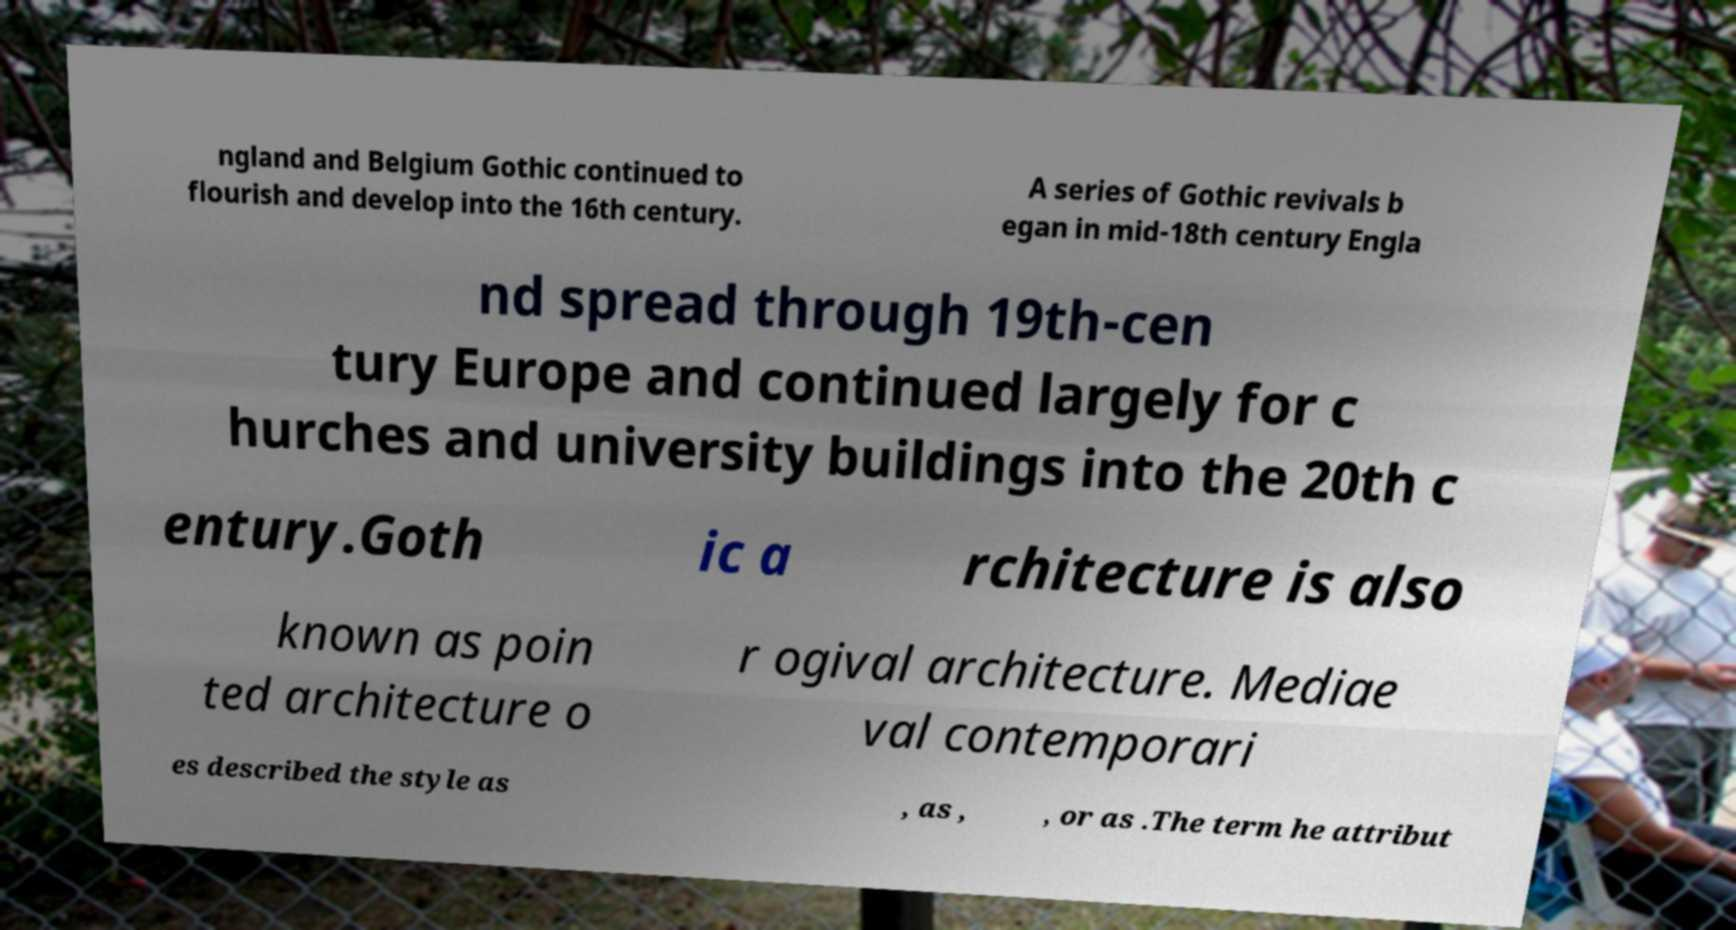There's text embedded in this image that I need extracted. Can you transcribe it verbatim? ngland and Belgium Gothic continued to flourish and develop into the 16th century. A series of Gothic revivals b egan in mid-18th century Engla nd spread through 19th-cen tury Europe and continued largely for c hurches and university buildings into the 20th c entury.Goth ic a rchitecture is also known as poin ted architecture o r ogival architecture. Mediae val contemporari es described the style as , as , , or as .The term he attribut 